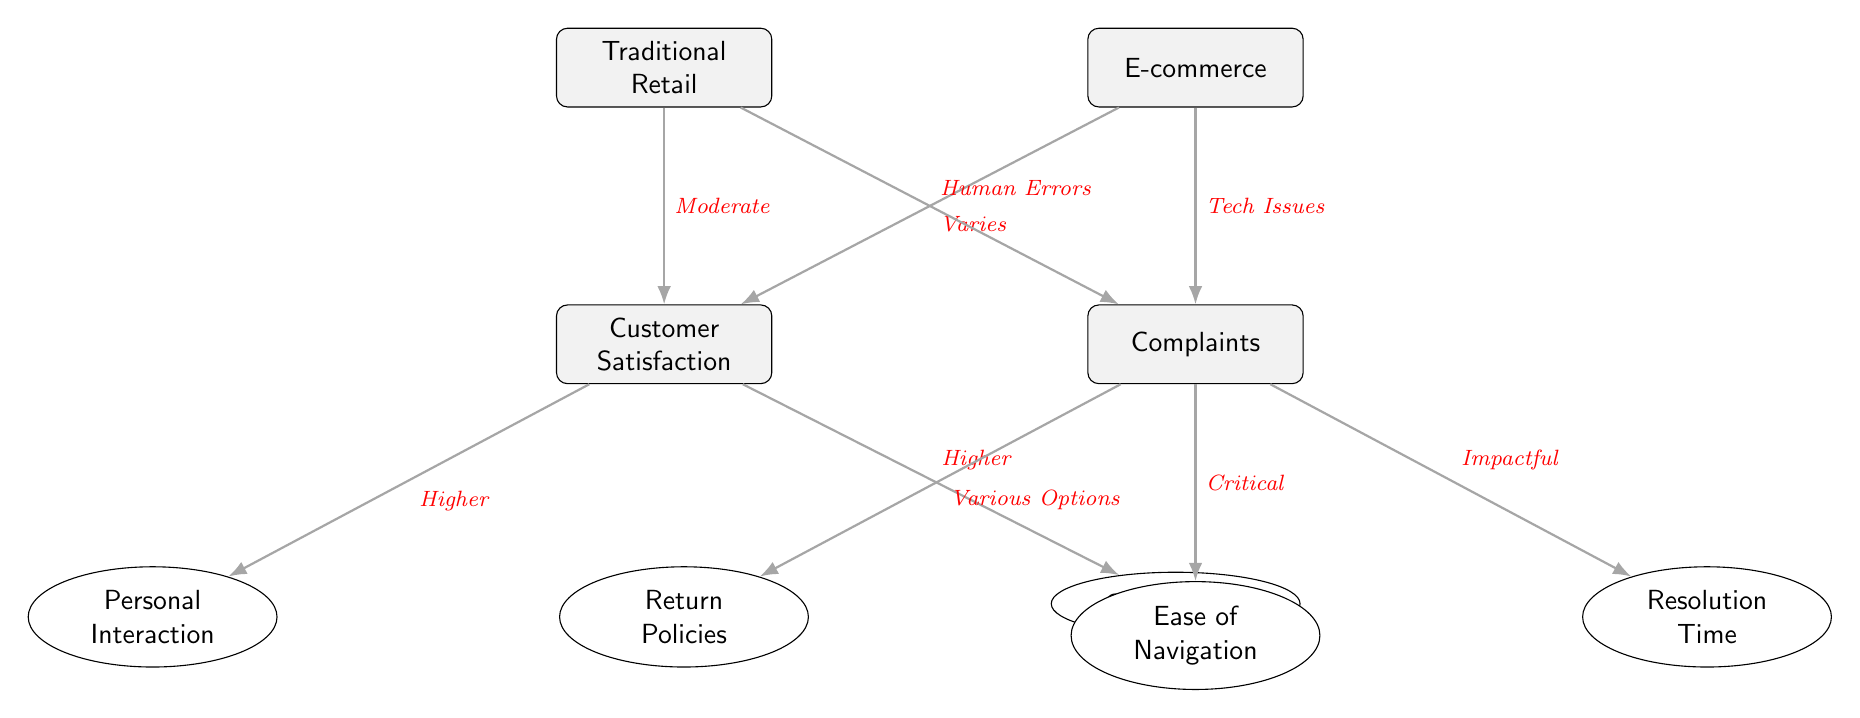What is the type of customer satisfaction associated with traditional retail? According to the diagram, the relationship is labeled as "Moderate" between Traditional Retail and Customer Satisfaction.
Answer: Moderate What type of issues are related to complaints in e-commerce? The diagram indicates that "Tech Issues" are specifically associated with complaints in e-commerce.
Answer: Tech Issues How many main nodes are there in the diagram? By counting, we can see there are four main nodes: Traditional Retail, E-commerce, Customer Satisfaction, and Complaints.
Answer: 4 What is the relationship between customer satisfaction and interaction? The diagram shows a higher level of customer satisfaction is linked to personal interaction, indicated by the phrase "Higher."
Answer: Higher What do return policies relate to in the context of complaints? The diagram shows that return policies are related to complaints through the description "Various Options."
Answer: Various Options What type of navigation issues are emphasized in the complaints section? The relationship highlighted in the diagram is labeled as "Critical," which describes the navigation issues.
Answer: Critical How is convenience related to customer satisfaction in e-commerce? The relationship shown in the diagram between customer satisfaction and convenience is denoted as "Higher."
Answer: Higher Which sub-node has a direct association with complaints that concerns the speed of issue resolution? The resolution time is identified in the diagram as being impacted, thus linking it under complaints with the label "Impactful."
Answer: Impactful What is the overall relationship type between e-commerce and customer satisfaction? The diagram indicates that this relationship varies, labeled as "Varies" in connection with customer satisfaction.
Answer: Varies 